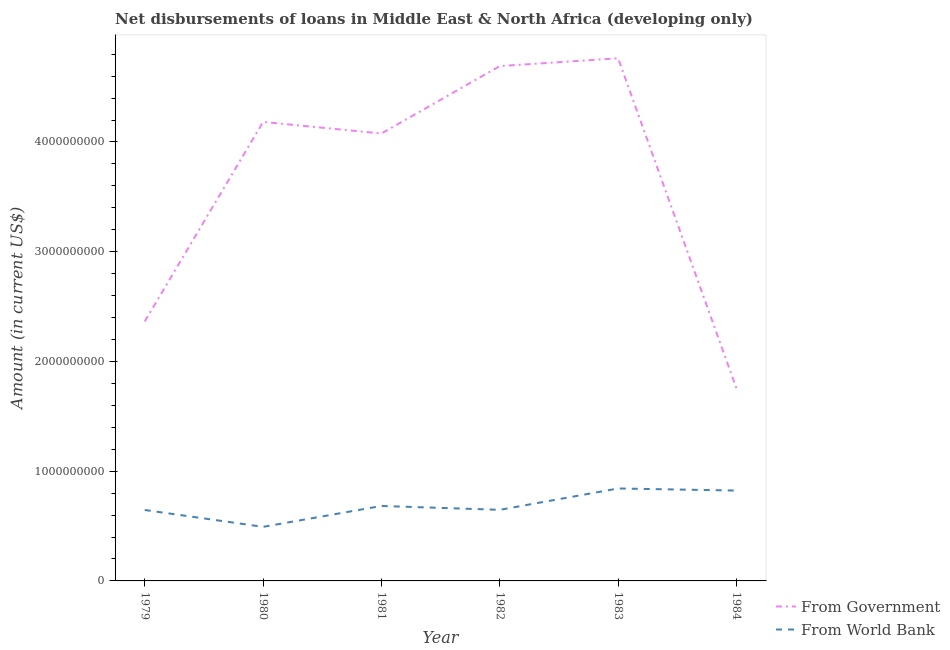How many different coloured lines are there?
Give a very brief answer. 2. What is the net disbursements of loan from government in 1981?
Keep it short and to the point. 4.08e+09. Across all years, what is the maximum net disbursements of loan from world bank?
Offer a terse response. 8.43e+08. Across all years, what is the minimum net disbursements of loan from world bank?
Keep it short and to the point. 4.93e+08. In which year was the net disbursements of loan from world bank minimum?
Offer a terse response. 1980. What is the total net disbursements of loan from world bank in the graph?
Offer a terse response. 4.14e+09. What is the difference between the net disbursements of loan from government in 1980 and that in 1983?
Ensure brevity in your answer.  -5.80e+08. What is the difference between the net disbursements of loan from world bank in 1979 and the net disbursements of loan from government in 1983?
Your response must be concise. -4.12e+09. What is the average net disbursements of loan from world bank per year?
Make the answer very short. 6.89e+08. In the year 1984, what is the difference between the net disbursements of loan from world bank and net disbursements of loan from government?
Give a very brief answer. -9.31e+08. What is the ratio of the net disbursements of loan from government in 1979 to that in 1980?
Your answer should be very brief. 0.57. Is the net disbursements of loan from government in 1983 less than that in 1984?
Your answer should be compact. No. Is the difference between the net disbursements of loan from government in 1979 and 1981 greater than the difference between the net disbursements of loan from world bank in 1979 and 1981?
Make the answer very short. No. What is the difference between the highest and the second highest net disbursements of loan from government?
Provide a succinct answer. 7.08e+07. What is the difference between the highest and the lowest net disbursements of loan from government?
Make the answer very short. 3.01e+09. How many lines are there?
Your response must be concise. 2. What is the difference between two consecutive major ticks on the Y-axis?
Offer a very short reply. 1.00e+09. Are the values on the major ticks of Y-axis written in scientific E-notation?
Provide a short and direct response. No. Where does the legend appear in the graph?
Your answer should be very brief. Bottom right. How are the legend labels stacked?
Offer a very short reply. Vertical. What is the title of the graph?
Offer a very short reply. Net disbursements of loans in Middle East & North Africa (developing only). Does "Quality of trade" appear as one of the legend labels in the graph?
Your response must be concise. No. What is the label or title of the X-axis?
Offer a terse response. Year. What is the label or title of the Y-axis?
Ensure brevity in your answer.  Amount (in current US$). What is the Amount (in current US$) of From Government in 1979?
Keep it short and to the point. 2.36e+09. What is the Amount (in current US$) of From World Bank in 1979?
Offer a terse response. 6.46e+08. What is the Amount (in current US$) of From Government in 1980?
Make the answer very short. 4.18e+09. What is the Amount (in current US$) in From World Bank in 1980?
Provide a succinct answer. 4.93e+08. What is the Amount (in current US$) of From Government in 1981?
Your answer should be compact. 4.08e+09. What is the Amount (in current US$) in From World Bank in 1981?
Keep it short and to the point. 6.83e+08. What is the Amount (in current US$) in From Government in 1982?
Give a very brief answer. 4.69e+09. What is the Amount (in current US$) in From World Bank in 1982?
Your answer should be very brief. 6.48e+08. What is the Amount (in current US$) in From Government in 1983?
Provide a short and direct response. 4.76e+09. What is the Amount (in current US$) in From World Bank in 1983?
Make the answer very short. 8.43e+08. What is the Amount (in current US$) in From Government in 1984?
Your answer should be compact. 1.75e+09. What is the Amount (in current US$) in From World Bank in 1984?
Give a very brief answer. 8.23e+08. Across all years, what is the maximum Amount (in current US$) of From Government?
Make the answer very short. 4.76e+09. Across all years, what is the maximum Amount (in current US$) in From World Bank?
Offer a terse response. 8.43e+08. Across all years, what is the minimum Amount (in current US$) of From Government?
Provide a succinct answer. 1.75e+09. Across all years, what is the minimum Amount (in current US$) in From World Bank?
Provide a short and direct response. 4.93e+08. What is the total Amount (in current US$) of From Government in the graph?
Your answer should be very brief. 2.18e+1. What is the total Amount (in current US$) of From World Bank in the graph?
Your answer should be compact. 4.14e+09. What is the difference between the Amount (in current US$) of From Government in 1979 and that in 1980?
Offer a terse response. -1.82e+09. What is the difference between the Amount (in current US$) of From World Bank in 1979 and that in 1980?
Ensure brevity in your answer.  1.54e+08. What is the difference between the Amount (in current US$) of From Government in 1979 and that in 1981?
Ensure brevity in your answer.  -1.71e+09. What is the difference between the Amount (in current US$) in From World Bank in 1979 and that in 1981?
Offer a very short reply. -3.67e+07. What is the difference between the Amount (in current US$) in From Government in 1979 and that in 1982?
Provide a short and direct response. -2.33e+09. What is the difference between the Amount (in current US$) in From World Bank in 1979 and that in 1982?
Your response must be concise. -1.47e+06. What is the difference between the Amount (in current US$) of From Government in 1979 and that in 1983?
Keep it short and to the point. -2.40e+09. What is the difference between the Amount (in current US$) of From World Bank in 1979 and that in 1983?
Provide a short and direct response. -1.96e+08. What is the difference between the Amount (in current US$) in From Government in 1979 and that in 1984?
Offer a terse response. 6.10e+08. What is the difference between the Amount (in current US$) in From World Bank in 1979 and that in 1984?
Give a very brief answer. -1.77e+08. What is the difference between the Amount (in current US$) of From Government in 1980 and that in 1981?
Offer a very short reply. 1.05e+08. What is the difference between the Amount (in current US$) of From World Bank in 1980 and that in 1981?
Your answer should be compact. -1.90e+08. What is the difference between the Amount (in current US$) in From Government in 1980 and that in 1982?
Give a very brief answer. -5.09e+08. What is the difference between the Amount (in current US$) of From World Bank in 1980 and that in 1982?
Offer a terse response. -1.55e+08. What is the difference between the Amount (in current US$) of From Government in 1980 and that in 1983?
Make the answer very short. -5.80e+08. What is the difference between the Amount (in current US$) of From World Bank in 1980 and that in 1983?
Your response must be concise. -3.50e+08. What is the difference between the Amount (in current US$) in From Government in 1980 and that in 1984?
Your response must be concise. 2.43e+09. What is the difference between the Amount (in current US$) in From World Bank in 1980 and that in 1984?
Provide a succinct answer. -3.31e+08. What is the difference between the Amount (in current US$) in From Government in 1981 and that in 1982?
Offer a very short reply. -6.14e+08. What is the difference between the Amount (in current US$) in From World Bank in 1981 and that in 1982?
Your answer should be very brief. 3.52e+07. What is the difference between the Amount (in current US$) in From Government in 1981 and that in 1983?
Keep it short and to the point. -6.85e+08. What is the difference between the Amount (in current US$) in From World Bank in 1981 and that in 1983?
Offer a very short reply. -1.59e+08. What is the difference between the Amount (in current US$) of From Government in 1981 and that in 1984?
Ensure brevity in your answer.  2.32e+09. What is the difference between the Amount (in current US$) of From World Bank in 1981 and that in 1984?
Your answer should be compact. -1.40e+08. What is the difference between the Amount (in current US$) of From Government in 1982 and that in 1983?
Ensure brevity in your answer.  -7.08e+07. What is the difference between the Amount (in current US$) of From World Bank in 1982 and that in 1983?
Give a very brief answer. -1.95e+08. What is the difference between the Amount (in current US$) in From Government in 1982 and that in 1984?
Make the answer very short. 2.94e+09. What is the difference between the Amount (in current US$) in From World Bank in 1982 and that in 1984?
Your answer should be compact. -1.76e+08. What is the difference between the Amount (in current US$) of From Government in 1983 and that in 1984?
Ensure brevity in your answer.  3.01e+09. What is the difference between the Amount (in current US$) in From World Bank in 1983 and that in 1984?
Your response must be concise. 1.90e+07. What is the difference between the Amount (in current US$) of From Government in 1979 and the Amount (in current US$) of From World Bank in 1980?
Offer a terse response. 1.87e+09. What is the difference between the Amount (in current US$) of From Government in 1979 and the Amount (in current US$) of From World Bank in 1981?
Make the answer very short. 1.68e+09. What is the difference between the Amount (in current US$) of From Government in 1979 and the Amount (in current US$) of From World Bank in 1982?
Provide a short and direct response. 1.72e+09. What is the difference between the Amount (in current US$) of From Government in 1979 and the Amount (in current US$) of From World Bank in 1983?
Keep it short and to the point. 1.52e+09. What is the difference between the Amount (in current US$) of From Government in 1979 and the Amount (in current US$) of From World Bank in 1984?
Offer a very short reply. 1.54e+09. What is the difference between the Amount (in current US$) of From Government in 1980 and the Amount (in current US$) of From World Bank in 1981?
Make the answer very short. 3.50e+09. What is the difference between the Amount (in current US$) in From Government in 1980 and the Amount (in current US$) in From World Bank in 1982?
Make the answer very short. 3.53e+09. What is the difference between the Amount (in current US$) in From Government in 1980 and the Amount (in current US$) in From World Bank in 1983?
Offer a terse response. 3.34e+09. What is the difference between the Amount (in current US$) of From Government in 1980 and the Amount (in current US$) of From World Bank in 1984?
Offer a very short reply. 3.36e+09. What is the difference between the Amount (in current US$) in From Government in 1981 and the Amount (in current US$) in From World Bank in 1982?
Offer a terse response. 3.43e+09. What is the difference between the Amount (in current US$) in From Government in 1981 and the Amount (in current US$) in From World Bank in 1983?
Provide a succinct answer. 3.23e+09. What is the difference between the Amount (in current US$) of From Government in 1981 and the Amount (in current US$) of From World Bank in 1984?
Your answer should be compact. 3.25e+09. What is the difference between the Amount (in current US$) in From Government in 1982 and the Amount (in current US$) in From World Bank in 1983?
Ensure brevity in your answer.  3.85e+09. What is the difference between the Amount (in current US$) in From Government in 1982 and the Amount (in current US$) in From World Bank in 1984?
Your answer should be compact. 3.87e+09. What is the difference between the Amount (in current US$) in From Government in 1983 and the Amount (in current US$) in From World Bank in 1984?
Give a very brief answer. 3.94e+09. What is the average Amount (in current US$) of From Government per year?
Your response must be concise. 3.64e+09. What is the average Amount (in current US$) of From World Bank per year?
Provide a succinct answer. 6.89e+08. In the year 1979, what is the difference between the Amount (in current US$) in From Government and Amount (in current US$) in From World Bank?
Your response must be concise. 1.72e+09. In the year 1980, what is the difference between the Amount (in current US$) in From Government and Amount (in current US$) in From World Bank?
Make the answer very short. 3.69e+09. In the year 1981, what is the difference between the Amount (in current US$) of From Government and Amount (in current US$) of From World Bank?
Your answer should be compact. 3.39e+09. In the year 1982, what is the difference between the Amount (in current US$) in From Government and Amount (in current US$) in From World Bank?
Ensure brevity in your answer.  4.04e+09. In the year 1983, what is the difference between the Amount (in current US$) of From Government and Amount (in current US$) of From World Bank?
Offer a very short reply. 3.92e+09. In the year 1984, what is the difference between the Amount (in current US$) in From Government and Amount (in current US$) in From World Bank?
Your answer should be very brief. 9.31e+08. What is the ratio of the Amount (in current US$) in From Government in 1979 to that in 1980?
Make the answer very short. 0.57. What is the ratio of the Amount (in current US$) in From World Bank in 1979 to that in 1980?
Offer a terse response. 1.31. What is the ratio of the Amount (in current US$) in From Government in 1979 to that in 1981?
Give a very brief answer. 0.58. What is the ratio of the Amount (in current US$) of From World Bank in 1979 to that in 1981?
Make the answer very short. 0.95. What is the ratio of the Amount (in current US$) of From Government in 1979 to that in 1982?
Offer a terse response. 0.5. What is the ratio of the Amount (in current US$) of From World Bank in 1979 to that in 1982?
Keep it short and to the point. 1. What is the ratio of the Amount (in current US$) in From Government in 1979 to that in 1983?
Offer a terse response. 0.5. What is the ratio of the Amount (in current US$) in From World Bank in 1979 to that in 1983?
Provide a succinct answer. 0.77. What is the ratio of the Amount (in current US$) of From Government in 1979 to that in 1984?
Offer a terse response. 1.35. What is the ratio of the Amount (in current US$) of From World Bank in 1979 to that in 1984?
Offer a terse response. 0.79. What is the ratio of the Amount (in current US$) in From Government in 1980 to that in 1981?
Provide a short and direct response. 1.03. What is the ratio of the Amount (in current US$) in From World Bank in 1980 to that in 1981?
Your response must be concise. 0.72. What is the ratio of the Amount (in current US$) in From Government in 1980 to that in 1982?
Keep it short and to the point. 0.89. What is the ratio of the Amount (in current US$) of From World Bank in 1980 to that in 1982?
Your answer should be compact. 0.76. What is the ratio of the Amount (in current US$) of From Government in 1980 to that in 1983?
Provide a succinct answer. 0.88. What is the ratio of the Amount (in current US$) in From World Bank in 1980 to that in 1983?
Your answer should be compact. 0.58. What is the ratio of the Amount (in current US$) of From Government in 1980 to that in 1984?
Provide a succinct answer. 2.38. What is the ratio of the Amount (in current US$) of From World Bank in 1980 to that in 1984?
Offer a terse response. 0.6. What is the ratio of the Amount (in current US$) of From Government in 1981 to that in 1982?
Make the answer very short. 0.87. What is the ratio of the Amount (in current US$) in From World Bank in 1981 to that in 1982?
Provide a succinct answer. 1.05. What is the ratio of the Amount (in current US$) in From Government in 1981 to that in 1983?
Ensure brevity in your answer.  0.86. What is the ratio of the Amount (in current US$) of From World Bank in 1981 to that in 1983?
Ensure brevity in your answer.  0.81. What is the ratio of the Amount (in current US$) in From Government in 1981 to that in 1984?
Your answer should be compact. 2.32. What is the ratio of the Amount (in current US$) in From World Bank in 1981 to that in 1984?
Your answer should be compact. 0.83. What is the ratio of the Amount (in current US$) of From Government in 1982 to that in 1983?
Offer a very short reply. 0.99. What is the ratio of the Amount (in current US$) of From World Bank in 1982 to that in 1983?
Provide a short and direct response. 0.77. What is the ratio of the Amount (in current US$) in From Government in 1982 to that in 1984?
Give a very brief answer. 2.67. What is the ratio of the Amount (in current US$) of From World Bank in 1982 to that in 1984?
Make the answer very short. 0.79. What is the ratio of the Amount (in current US$) in From Government in 1983 to that in 1984?
Give a very brief answer. 2.71. What is the ratio of the Amount (in current US$) of From World Bank in 1983 to that in 1984?
Make the answer very short. 1.02. What is the difference between the highest and the second highest Amount (in current US$) in From Government?
Give a very brief answer. 7.08e+07. What is the difference between the highest and the second highest Amount (in current US$) of From World Bank?
Your answer should be compact. 1.90e+07. What is the difference between the highest and the lowest Amount (in current US$) of From Government?
Give a very brief answer. 3.01e+09. What is the difference between the highest and the lowest Amount (in current US$) in From World Bank?
Keep it short and to the point. 3.50e+08. 